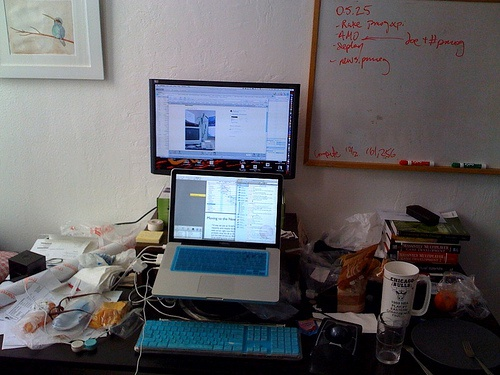Describe the objects in this image and their specific colors. I can see laptop in lightgray, gray, black, and lightblue tones, tv in lightgray, darkgray, black, and gray tones, keyboard in lightgray, blue, black, darkblue, and teal tones, cup in lightgray, black, and gray tones, and cup in lightgray, black, and gray tones in this image. 